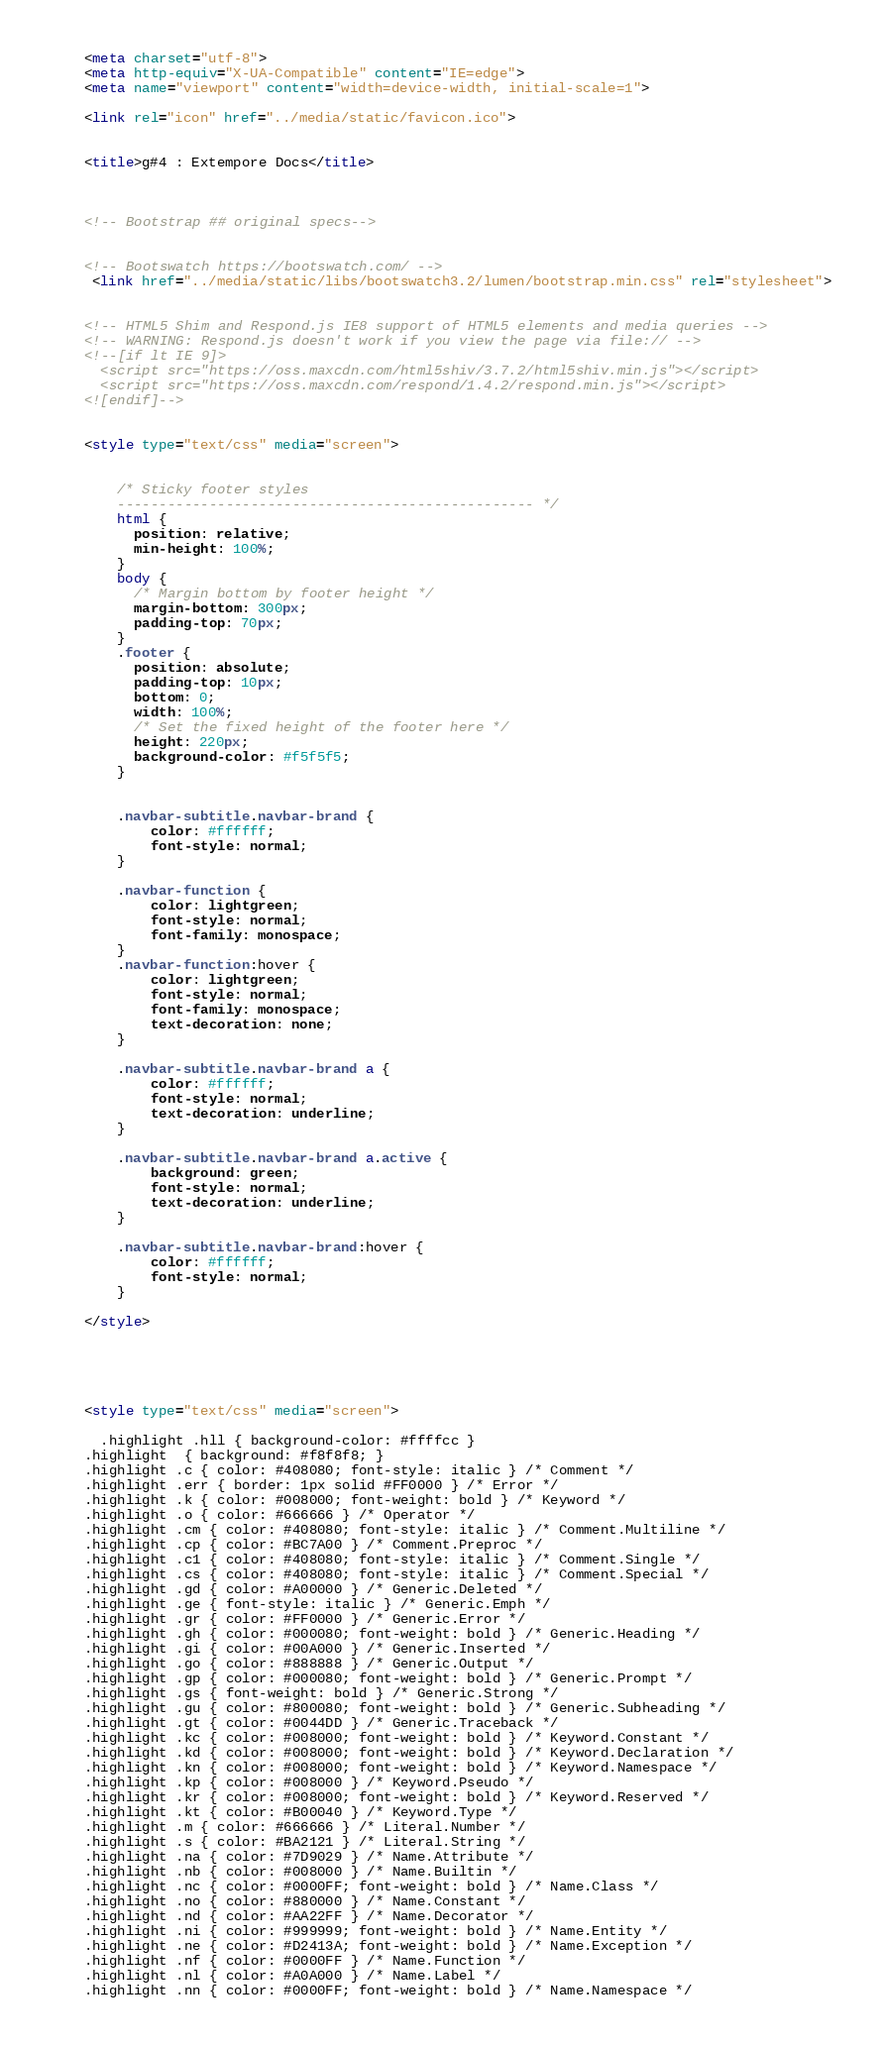<code> <loc_0><loc_0><loc_500><loc_500><_HTML_>
    <meta charset="utf-8">
    <meta http-equiv="X-UA-Compatible" content="IE=edge">
    <meta name="viewport" content="width=device-width, initial-scale=1">

	<link rel="icon" href="../media/static/favicon.ico">
    
	
	<title>g#4 : Extempore Docs</title>

	

    <!-- Bootstrap ## original specs-->
    
	
	<!-- Bootswatch https://bootswatch.com/ -->
	 <link href="../media/static/libs/bootswatch3.2/lumen/bootstrap.min.css" rel="stylesheet">
	 

    <!-- HTML5 Shim and Respond.js IE8 support of HTML5 elements and media queries -->
    <!-- WARNING: Respond.js doesn't work if you view the page via file:// -->
    <!--[if lt IE 9]>
      <script src="https://oss.maxcdn.com/html5shiv/3.7.2/html5shiv.min.js"></script>
      <script src="https://oss.maxcdn.com/respond/1.4.2/respond.min.js"></script>
    <![endif]-->
		
		
	<style type="text/css" media="screen">


		/* Sticky footer styles 
		-------------------------------------------------- */
		html {
		  position: relative;
		  min-height: 100%;
		}
		body {
		  /* Margin bottom by footer height */
		  margin-bottom: 300px;
		  padding-top: 70px;
		}
		.footer {
		  position: absolute;
		  padding-top: 10px;
		  bottom: 0;
		  width: 100%;
		  /* Set the fixed height of the footer here */
		  height: 220px;
		  background-color: #f5f5f5;
		}
		

		.navbar-subtitle.navbar-brand {
			color: #ffffff;
			font-style: normal;
		}

		.navbar-function {
			color: lightgreen;
			font-style: normal;
			font-family: monospace;
		}
		.navbar-function:hover {
			color: lightgreen;
			font-style: normal;
			font-family: monospace;
			text-decoration: none;
		}
		
		.navbar-subtitle.navbar-brand a {
			color: #ffffff;
			font-style: normal;
			text-decoration: underline;
		}

		.navbar-subtitle.navbar-brand a.active {
			background: green;
			font-style: normal;
			text-decoration: underline;
		}

		.navbar-subtitle.navbar-brand:hover {
			color: #ffffff;
			font-style: normal;
		}
		
	</style>	
		
		
	
	
	
	<style type="text/css" media="screen">

	  .highlight .hll { background-color: #ffffcc }
	.highlight  { background: #f8f8f8; }
	.highlight .c { color: #408080; font-style: italic } /* Comment */
	.highlight .err { border: 1px solid #FF0000 } /* Error */
	.highlight .k { color: #008000; font-weight: bold } /* Keyword */
	.highlight .o { color: #666666 } /* Operator */
	.highlight .cm { color: #408080; font-style: italic } /* Comment.Multiline */
	.highlight .cp { color: #BC7A00 } /* Comment.Preproc */
	.highlight .c1 { color: #408080; font-style: italic } /* Comment.Single */
	.highlight .cs { color: #408080; font-style: italic } /* Comment.Special */
	.highlight .gd { color: #A00000 } /* Generic.Deleted */
	.highlight .ge { font-style: italic } /* Generic.Emph */
	.highlight .gr { color: #FF0000 } /* Generic.Error */
	.highlight .gh { color: #000080; font-weight: bold } /* Generic.Heading */
	.highlight .gi { color: #00A000 } /* Generic.Inserted */
	.highlight .go { color: #888888 } /* Generic.Output */
	.highlight .gp { color: #000080; font-weight: bold } /* Generic.Prompt */
	.highlight .gs { font-weight: bold } /* Generic.Strong */
	.highlight .gu { color: #800080; font-weight: bold } /* Generic.Subheading */
	.highlight .gt { color: #0044DD } /* Generic.Traceback */
	.highlight .kc { color: #008000; font-weight: bold } /* Keyword.Constant */
	.highlight .kd { color: #008000; font-weight: bold } /* Keyword.Declaration */
	.highlight .kn { color: #008000; font-weight: bold } /* Keyword.Namespace */
	.highlight .kp { color: #008000 } /* Keyword.Pseudo */
	.highlight .kr { color: #008000; font-weight: bold } /* Keyword.Reserved */
	.highlight .kt { color: #B00040 } /* Keyword.Type */
	.highlight .m { color: #666666 } /* Literal.Number */
	.highlight .s { color: #BA2121 } /* Literal.String */
	.highlight .na { color: #7D9029 } /* Name.Attribute */
	.highlight .nb { color: #008000 } /* Name.Builtin */
	.highlight .nc { color: #0000FF; font-weight: bold } /* Name.Class */
	.highlight .no { color: #880000 } /* Name.Constant */
	.highlight .nd { color: #AA22FF } /* Name.Decorator */
	.highlight .ni { color: #999999; font-weight: bold } /* Name.Entity */
	.highlight .ne { color: #D2413A; font-weight: bold } /* Name.Exception */
	.highlight .nf { color: #0000FF } /* Name.Function */
	.highlight .nl { color: #A0A000 } /* Name.Label */
	.highlight .nn { color: #0000FF; font-weight: bold } /* Name.Namespace */</code> 